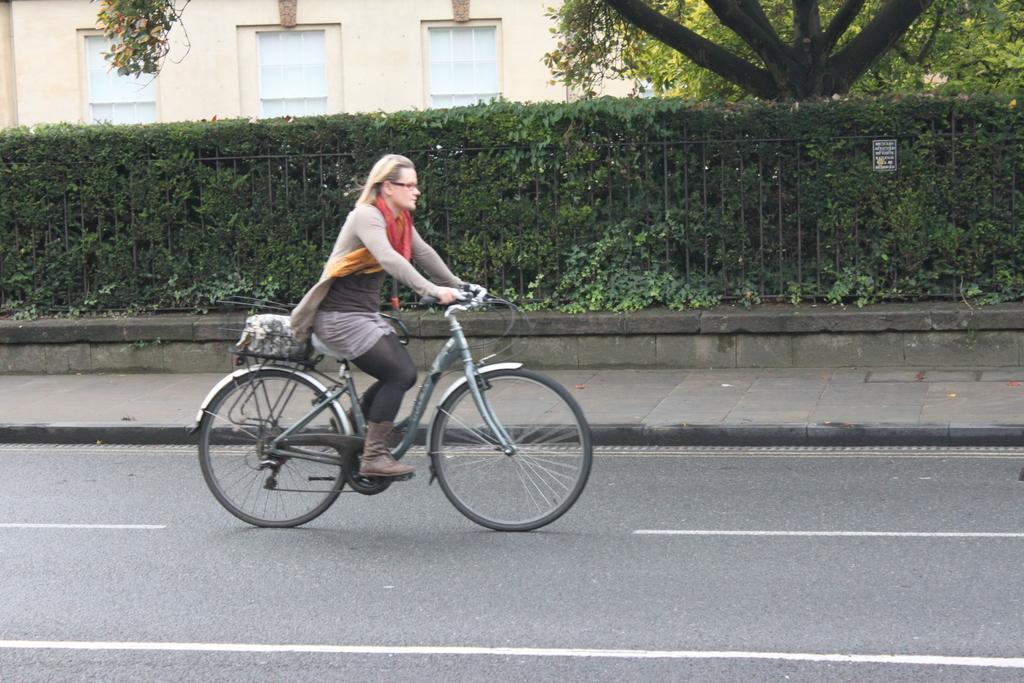Could you give a brief overview of what you see in this image? In this picture we can see woman riding bicycle and aside to this road we have foot path and fence and in background we can see wall with windows,tree, sticker to fence. 